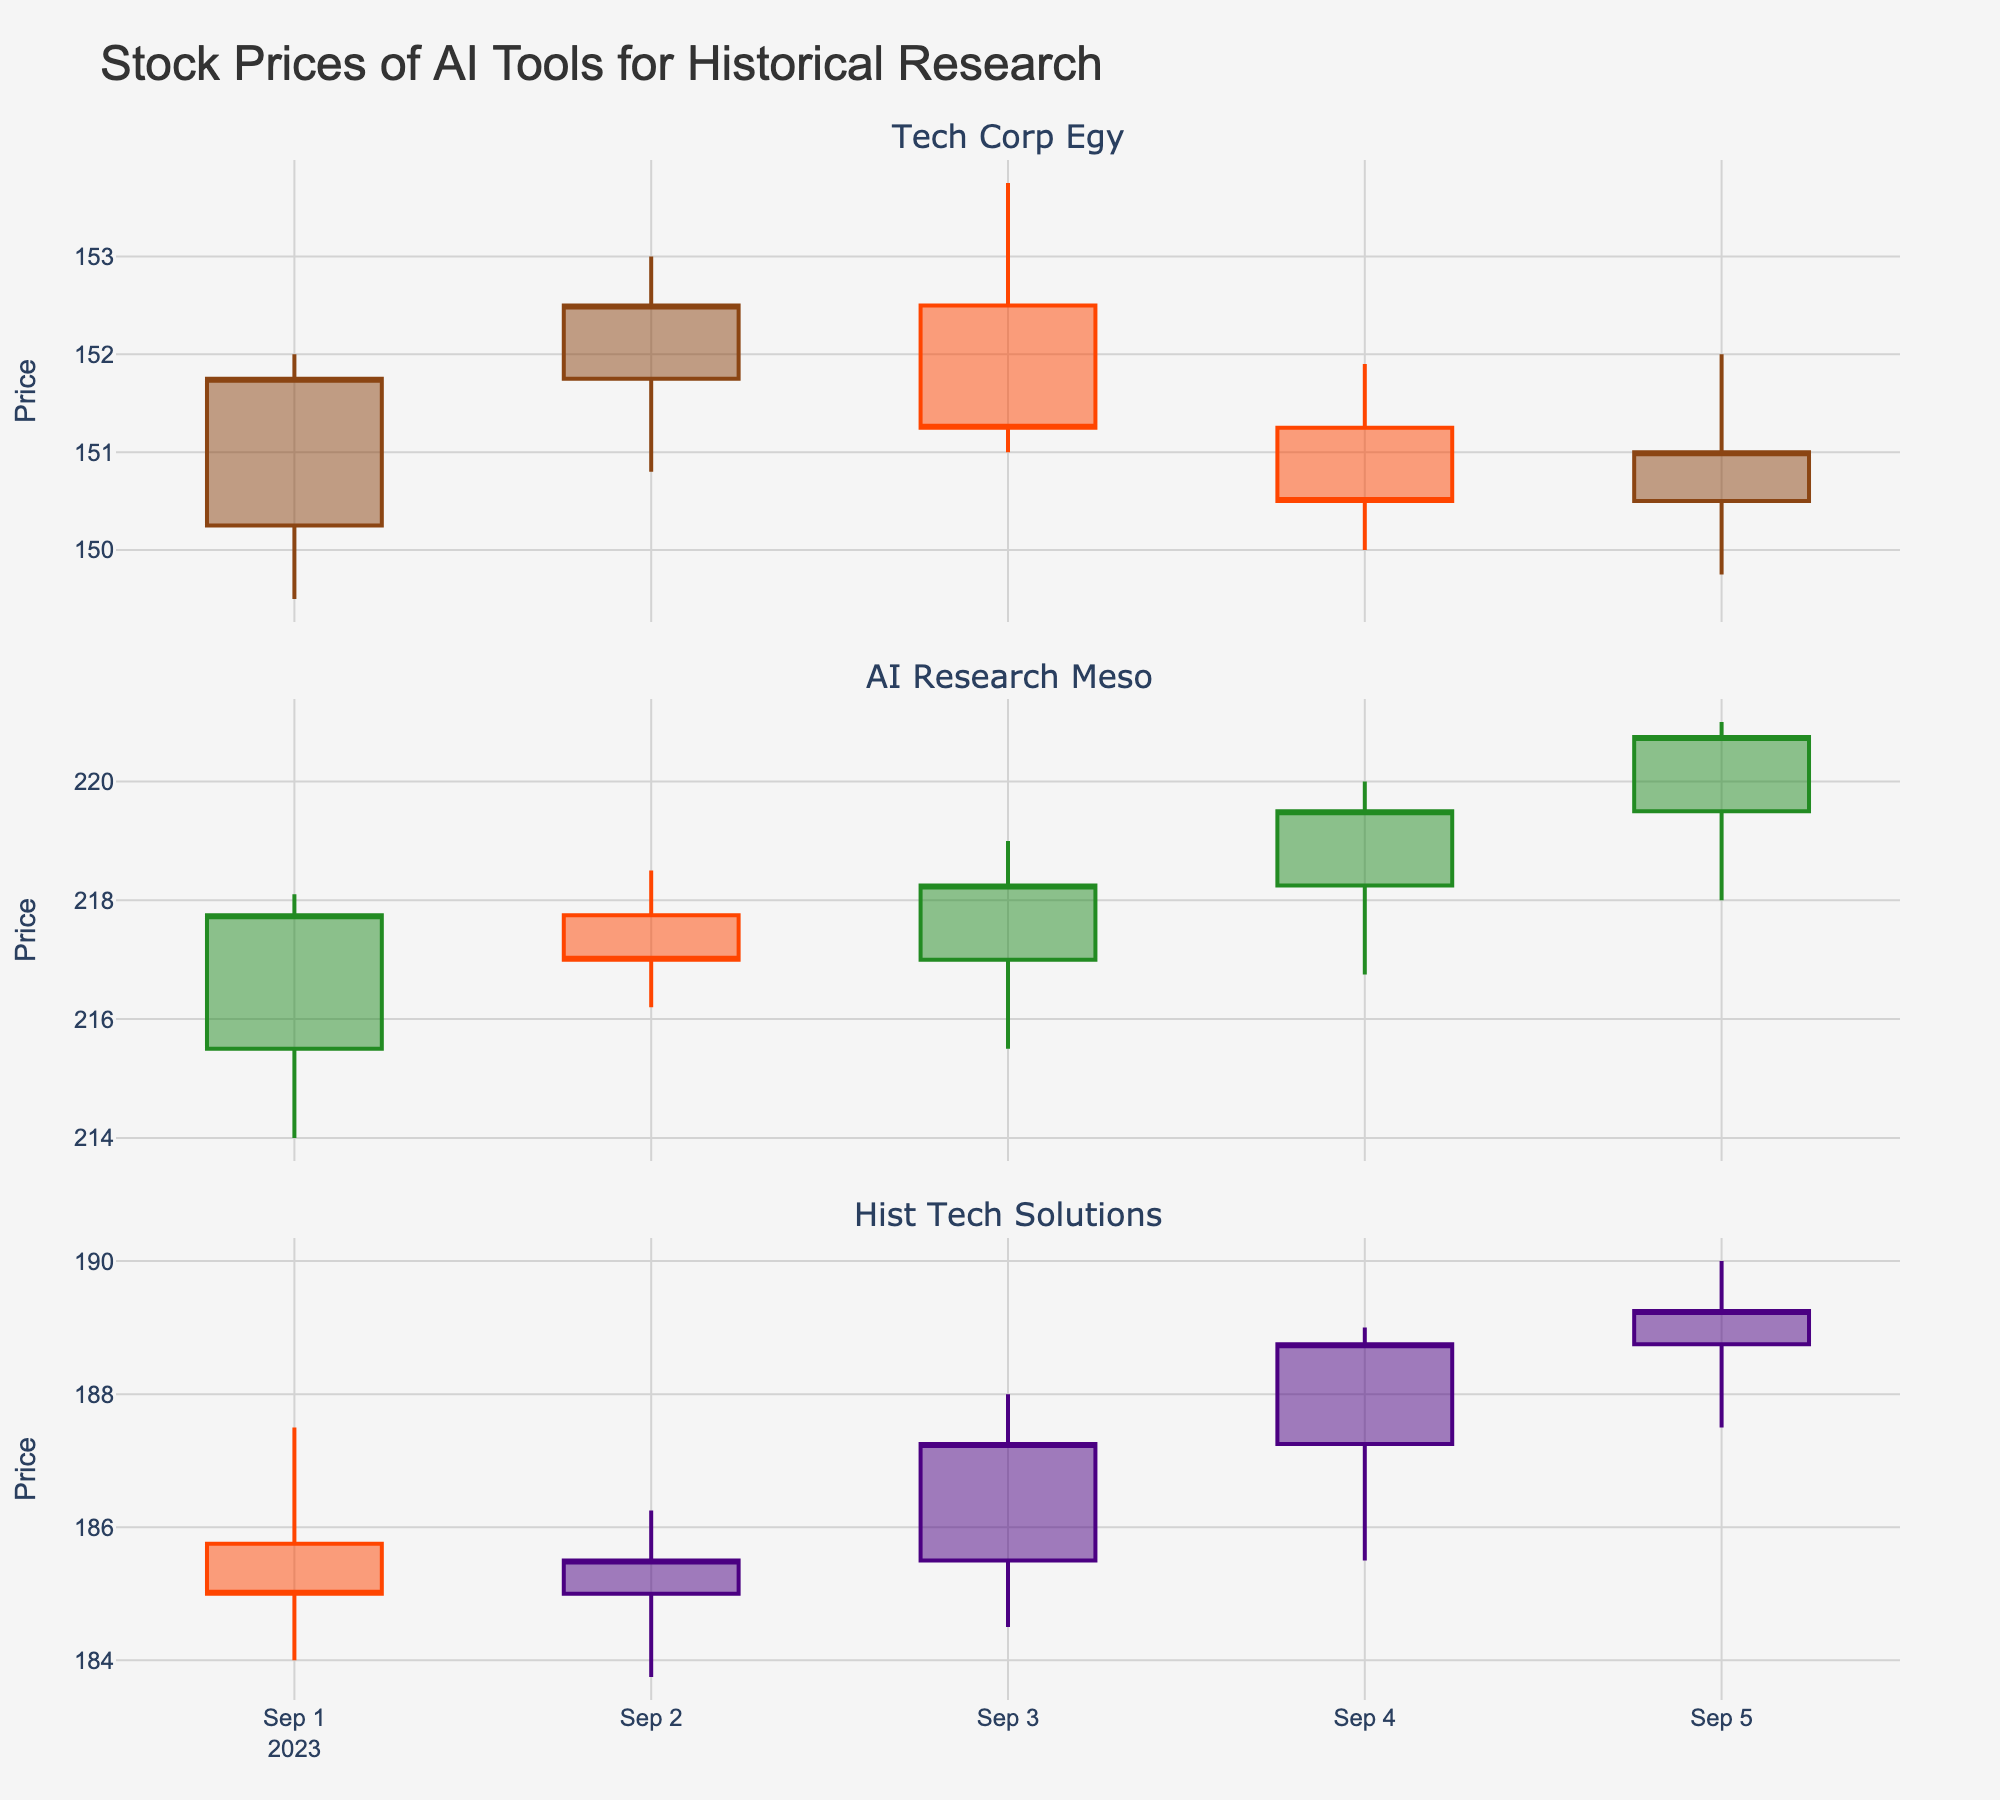Which firm's stock had the highest closing price on September 5th? Look at the closing prices for each firm on September 5th. Compare the closing prices: Tech Corp Egy closed at 151.00, AI Research Meso closed at 220.75, and Hist Tech Solutions closed at 189.25.
Answer: AI Research Meso How many days did Tech Corp Egy have an increasing trend in closing prices? Analyze the closing prices of Tech Corp Egy and count the number of days where the closing price is higher than the previous day's closing price. The trend is increasing only on September 2nd.
Answer: 1 What is the average closing price for AI Research Meso over the given dates? Sum up the closing prices for each day for AI Research Meso: 217.75 + 217.00 + 218.25 + 219.50 + 220.75 = 1093.25. Then divide by the number of days (5): 1093.25 / 5 = 218.65.
Answer: 218.65 Which firm had the most volatile high prices over the given dates? Volatility can be analyzed by looking at the range between the highest high and the lowest high price for each firm. Tech Corp Egy: 153.75 - 151.90 = 1.85, AI Research Meso: 221.00 - 218.10 = 2.90, Hist Tech Solutions: 190.00 - 187.50 = 2.50. The most volatile is AI Research Meso.
Answer: AI Research Meso On which date did Hist Tech Solutions have the smallest difference between its high and low prices? Calculate the difference between high and low prices for each day: September 1st: 3.50, September 2nd: 2.50, September 3rd: 3.50, September 4th: 3.50, September 5th: 2.50. The smallest differences are on September 2nd and 5th.
Answer: September 2nd and September 5th Comparing September 3rd, which firm had the highest intraday range (difference between high and low prices)? Calculate the ranges: Tech Corp Egy: 153.75 - 151.00 = 2.75, AI Research Meso: 219.00 - 215.50 = 3.50, Hist Tech Solutions: 188.00 - 184.50 = 3.50. Both AI Research Meso and Hist Tech Solutions had the highest range of 3.50.
Answer: AI Research Meso and Hist Tech Solutions On how many days did AI Research Meso's stock price close higher than its opening price? Compare the opening and closing prices for AI Research Meso for each day. The closing price was higher on September 1st, September 3rd, September 4th, and September 5th.
Answer: 4 What was the total trading volume for Tech Corp Egy over all five days? Sum the daily trading volumes for Tech Corp Egy: 1200000 + 1300000 + 1350000 + 1100000 + 1250000 = 6200000.
Answer: 6200000 